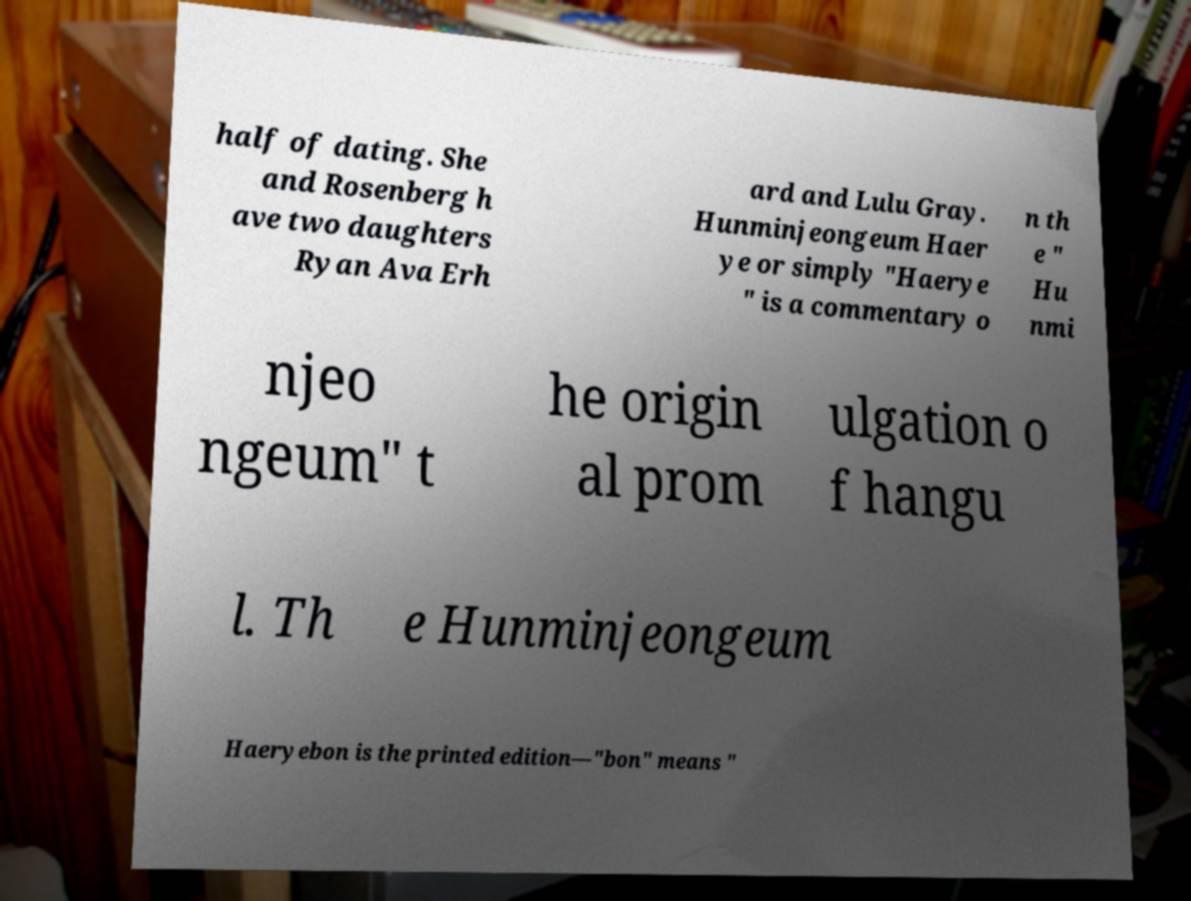There's text embedded in this image that I need extracted. Can you transcribe it verbatim? half of dating. She and Rosenberg h ave two daughters Ryan Ava Erh ard and Lulu Gray. Hunminjeongeum Haer ye or simply "Haerye " is a commentary o n th e " Hu nmi njeo ngeum" t he origin al prom ulgation o f hangu l. Th e Hunminjeongeum Haeryebon is the printed edition—"bon" means " 